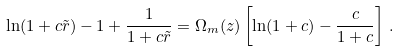<formula> <loc_0><loc_0><loc_500><loc_500>\ln ( 1 + c \tilde { r } ) - 1 + \frac { 1 } { 1 + c \tilde { r } } = \Omega _ { m } ( z ) \left [ \ln ( 1 + c ) - \frac { c } { 1 + c } \right ] \, .</formula> 